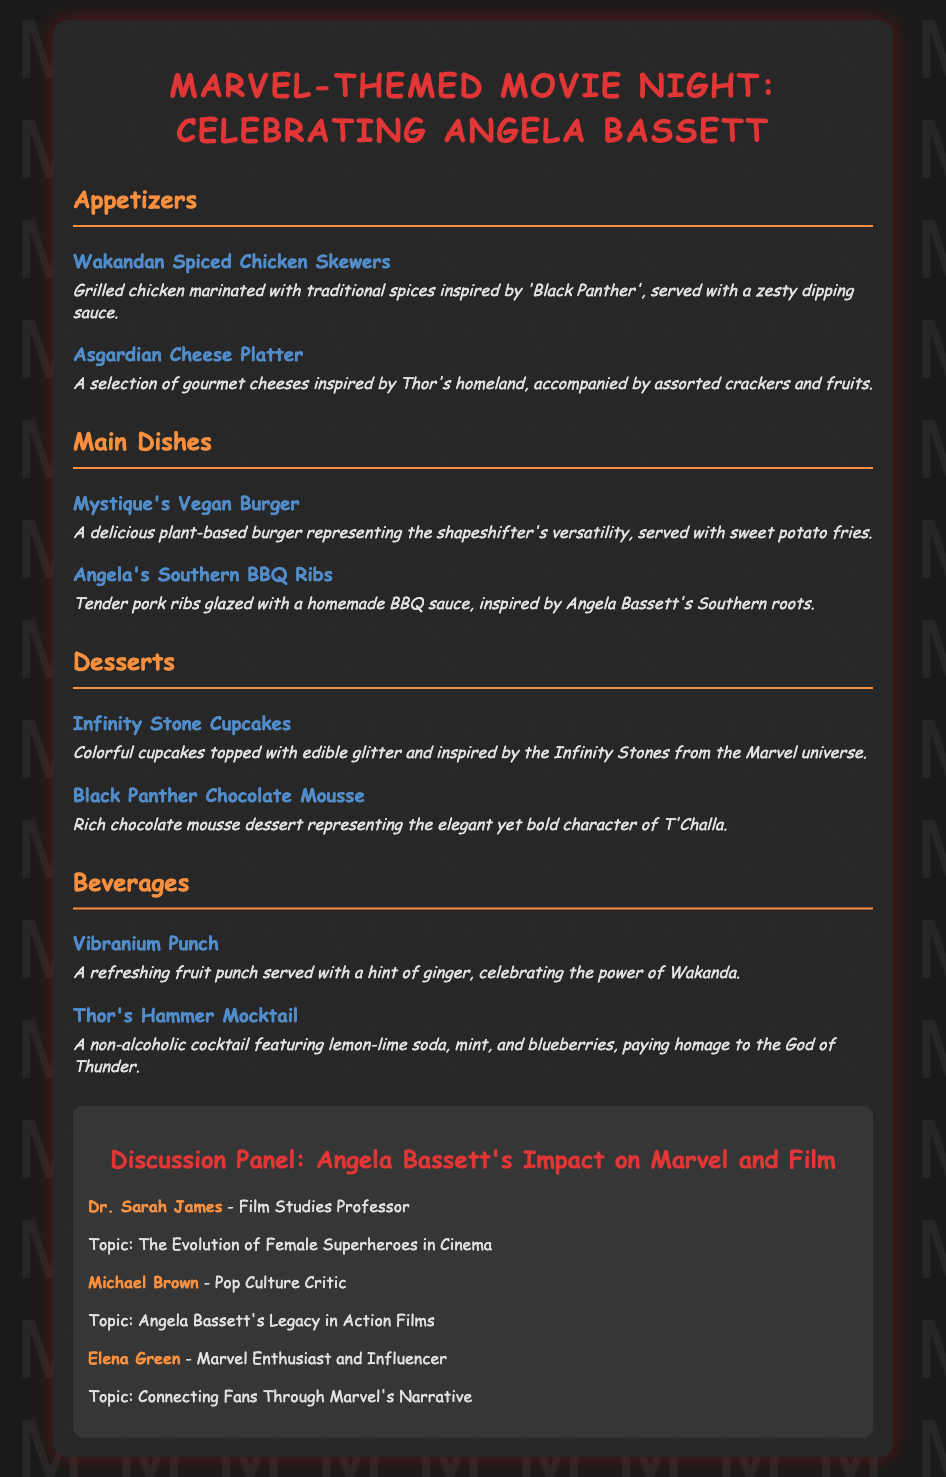What is the title of the event? The title of the event is prominently featured at the top of the document.
Answer: Marvel-Themed Movie Night: Celebrating Angela Bassett What is one of the appetizers listed? The document provides a list of appetizers, highlighting specific dishes.
Answer: Wakandan Spiced Chicken Skewers Which movie character inspires the dessert cup mentioned? The dessert is named after a character from the Marvel universe, connecting the theme to the dessert.
Answer: Infinity Stones Who is one of the panelists? The document includes information about the discussion panel and lists the names of the panelists.
Answer: Dr. Sarah James What is the main dish inspired by Angela Bassett's roots? The document specifies a dish that reflects Angela Bassett's background and connection to Southern cuisine.
Answer: Angela's Southern BBQ Ribs How many beverages are listed in the menu? By counting the menu section under beverages, we find the total number provided in the document.
Answer: Two What is the topic of discussion for Michael Brown? The document mentions the topics of discussion for each panelist, including Michael Brown's.
Answer: Angela Bassett's Legacy in Action Films What color scheme is used in the titles of the menu sections? The document describes the color used for the section titles, which provides a thematic feel.
Answer: Orange 